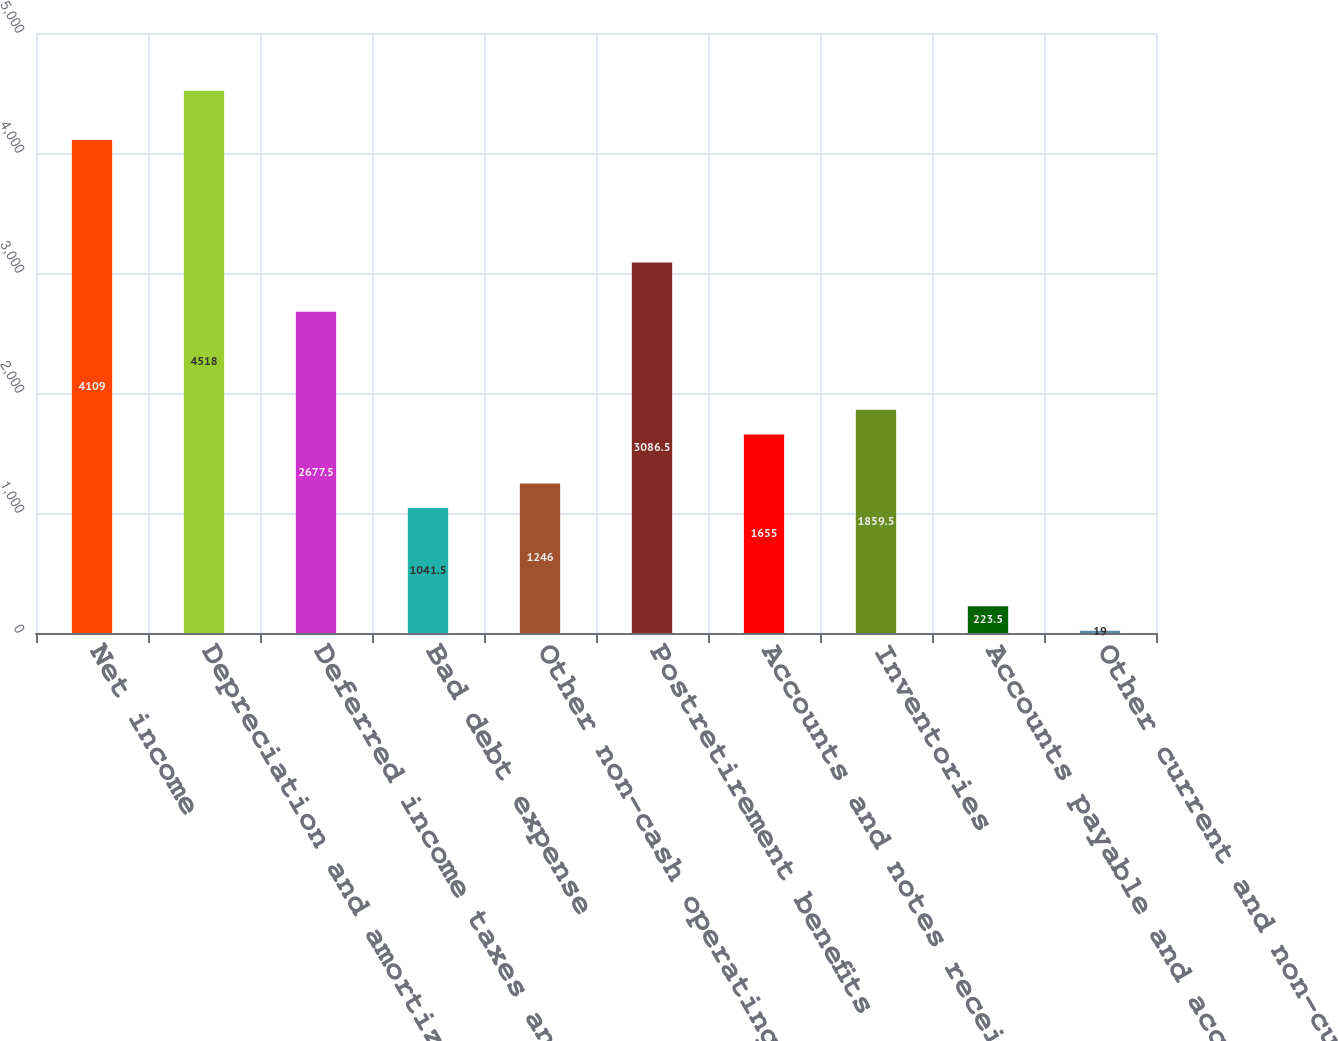Convert chart. <chart><loc_0><loc_0><loc_500><loc_500><bar_chart><fcel>Net income<fcel>Depreciation and amortization<fcel>Deferred income taxes and<fcel>Bad debt expense<fcel>Other non-cash operating<fcel>Postretirement benefits<fcel>Accounts and notes receivable<fcel>Inventories<fcel>Accounts payable and accrued<fcel>Other current and non-current<nl><fcel>4109<fcel>4518<fcel>2677.5<fcel>1041.5<fcel>1246<fcel>3086.5<fcel>1655<fcel>1859.5<fcel>223.5<fcel>19<nl></chart> 